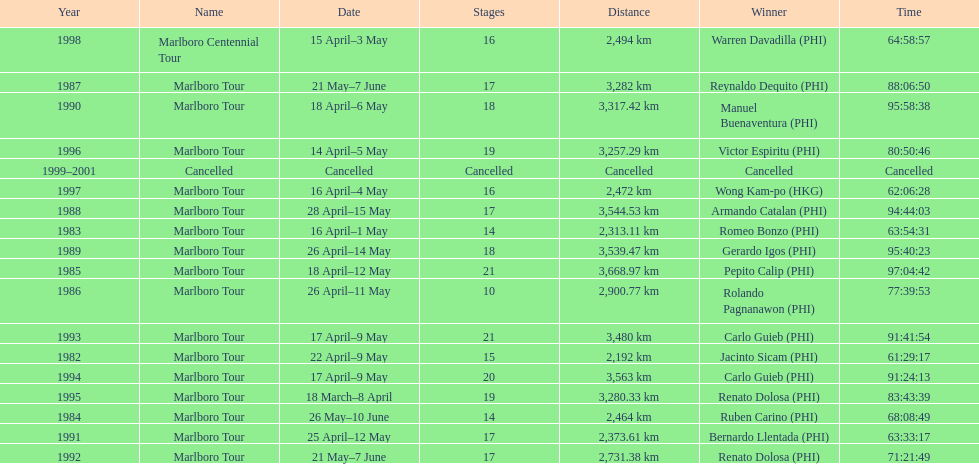Who is listed below romeo bonzo? Ruben Carino (PHI). 